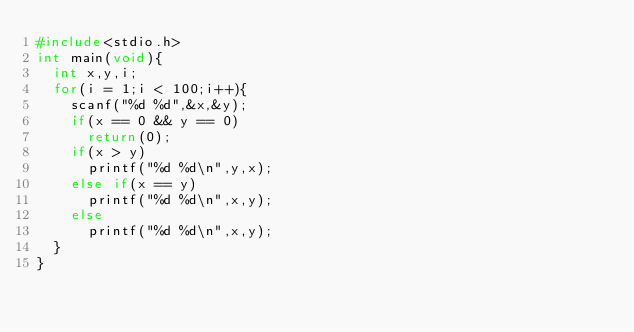<code> <loc_0><loc_0><loc_500><loc_500><_C_>#include<stdio.h>
int main(void){
  int x,y,i;
  for(i = 1;i < 100;i++){
    scanf("%d %d",&x,&y);
    if(x == 0 && y == 0)
      return(0);
    if(x > y)
      printf("%d %d\n",y,x);
    else if(x == y)
      printf("%d %d\n",x,y);
    else 
      printf("%d %d\n",x,y);
  }
}</code> 